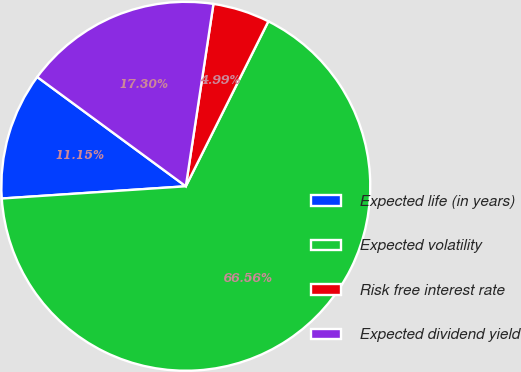Convert chart to OTSL. <chart><loc_0><loc_0><loc_500><loc_500><pie_chart><fcel>Expected life (in years)<fcel>Expected volatility<fcel>Risk free interest rate<fcel>Expected dividend yield<nl><fcel>11.15%<fcel>66.56%<fcel>4.99%<fcel>17.3%<nl></chart> 